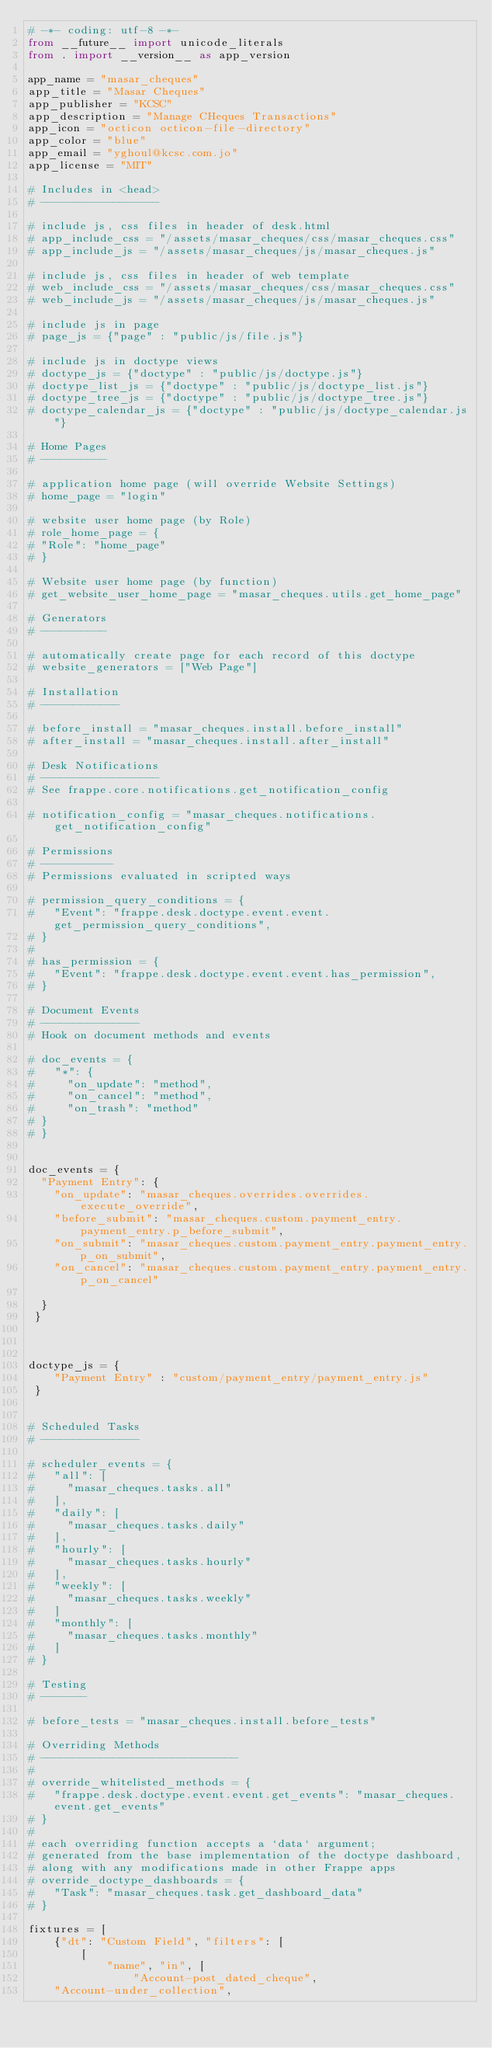Convert code to text. <code><loc_0><loc_0><loc_500><loc_500><_Python_># -*- coding: utf-8 -*-
from __future__ import unicode_literals
from . import __version__ as app_version

app_name = "masar_cheques"
app_title = "Masar Cheques"
app_publisher = "KCSC"
app_description = "Manage CHeques Transactions"
app_icon = "octicon octicon-file-directory"
app_color = "blue"
app_email = "yghoul@kcsc.com.jo"
app_license = "MIT"

# Includes in <head>
# ------------------

# include js, css files in header of desk.html
# app_include_css = "/assets/masar_cheques/css/masar_cheques.css"
# app_include_js = "/assets/masar_cheques/js/masar_cheques.js"

# include js, css files in header of web template
# web_include_css = "/assets/masar_cheques/css/masar_cheques.css"
# web_include_js = "/assets/masar_cheques/js/masar_cheques.js"

# include js in page
# page_js = {"page" : "public/js/file.js"}

# include js in doctype views
# doctype_js = {"doctype" : "public/js/doctype.js"}
# doctype_list_js = {"doctype" : "public/js/doctype_list.js"}
# doctype_tree_js = {"doctype" : "public/js/doctype_tree.js"}
# doctype_calendar_js = {"doctype" : "public/js/doctype_calendar.js"}

# Home Pages
# ----------

# application home page (will override Website Settings)
# home_page = "login"

# website user home page (by Role)
# role_home_page = {
#	"Role": "home_page"
# }

# Website user home page (by function)
# get_website_user_home_page = "masar_cheques.utils.get_home_page"

# Generators
# ----------

# automatically create page for each record of this doctype
# website_generators = ["Web Page"]

# Installation
# ------------

# before_install = "masar_cheques.install.before_install"
# after_install = "masar_cheques.install.after_install"

# Desk Notifications
# ------------------
# See frappe.core.notifications.get_notification_config

# notification_config = "masar_cheques.notifications.get_notification_config"

# Permissions
# -----------
# Permissions evaluated in scripted ways

# permission_query_conditions = {
# 	"Event": "frappe.desk.doctype.event.event.get_permission_query_conditions",
# }
#
# has_permission = {
# 	"Event": "frappe.desk.doctype.event.event.has_permission",
# }

# Document Events
# ---------------
# Hook on document methods and events

# doc_events = {
# 	"*": {
# 		"on_update": "method",
# 		"on_cancel": "method",
# 		"on_trash": "method"
#	}
# }


doc_events = {
 	"Payment Entry": {
 		"on_update": "masar_cheques.overrides.overrides.execute_override",
		"before_submit": "masar_cheques.custom.payment_entry.payment_entry.p_before_submit",
		"on_submit": "masar_cheques.custom.payment_entry.payment_entry.p_on_submit",
		"on_cancel": "masar_cheques.custom.payment_entry.payment_entry.p_on_cancel"

	}
 }



doctype_js = {
    "Payment Entry" : "custom/payment_entry/payment_entry.js"
 }


# Scheduled Tasks
# ---------------

# scheduler_events = {
# 	"all": [
# 		"masar_cheques.tasks.all"
# 	],
# 	"daily": [
# 		"masar_cheques.tasks.daily"
# 	],
# 	"hourly": [
# 		"masar_cheques.tasks.hourly"
# 	],
# 	"weekly": [
# 		"masar_cheques.tasks.weekly"
# 	]
# 	"monthly": [
# 		"masar_cheques.tasks.monthly"
# 	]
# }

# Testing
# -------

# before_tests = "masar_cheques.install.before_tests"

# Overriding Methods
# ------------------------------
#
# override_whitelisted_methods = {
# 	"frappe.desk.doctype.event.event.get_events": "masar_cheques.event.get_events"
# }
#
# each overriding function accepts a `data` argument;
# generated from the base implementation of the doctype dashboard,
# along with any modifications made in other Frappe apps
# override_doctype_dashboards = {
# 	"Task": "masar_cheques.task.get_dashboard_data"
# }

fixtures = [
    {"dt": "Custom Field", "filters": [
        [
            "name", "in", [
                "Account-post_dated_cheque",
		"Account-under_collection",</code> 